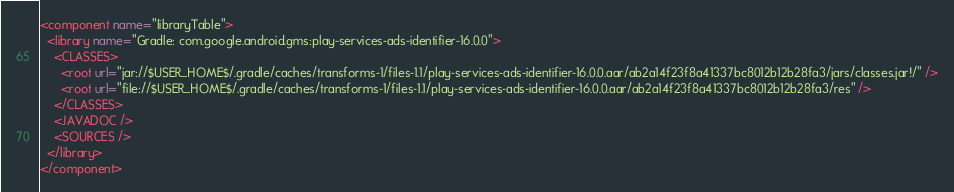Convert code to text. <code><loc_0><loc_0><loc_500><loc_500><_XML_><component name="libraryTable">
  <library name="Gradle: com.google.android.gms:play-services-ads-identifier-16.0.0">
    <CLASSES>
      <root url="jar://$USER_HOME$/.gradle/caches/transforms-1/files-1.1/play-services-ads-identifier-16.0.0.aar/ab2a14f23f8a41337bc8012b12b28fa3/jars/classes.jar!/" />
      <root url="file://$USER_HOME$/.gradle/caches/transforms-1/files-1.1/play-services-ads-identifier-16.0.0.aar/ab2a14f23f8a41337bc8012b12b28fa3/res" />
    </CLASSES>
    <JAVADOC />
    <SOURCES />
  </library>
</component></code> 